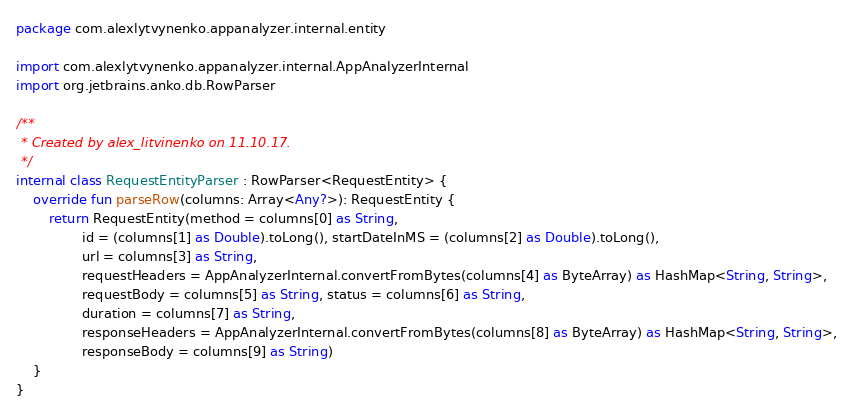<code> <loc_0><loc_0><loc_500><loc_500><_Kotlin_>package com.alexlytvynenko.appanalyzer.internal.entity

import com.alexlytvynenko.appanalyzer.internal.AppAnalyzerInternal
import org.jetbrains.anko.db.RowParser

/**
 * Created by alex_litvinenko on 11.10.17.
 */
internal class RequestEntityParser : RowParser<RequestEntity> {
    override fun parseRow(columns: Array<Any?>): RequestEntity {
        return RequestEntity(method = columns[0] as String,
                id = (columns[1] as Double).toLong(), startDateInMS = (columns[2] as Double).toLong(),
                url = columns[3] as String,
                requestHeaders = AppAnalyzerInternal.convertFromBytes(columns[4] as ByteArray) as HashMap<String, String>,
                requestBody = columns[5] as String, status = columns[6] as String,
                duration = columns[7] as String,
                responseHeaders = AppAnalyzerInternal.convertFromBytes(columns[8] as ByteArray) as HashMap<String, String>,
                responseBody = columns[9] as String)
    }
}</code> 